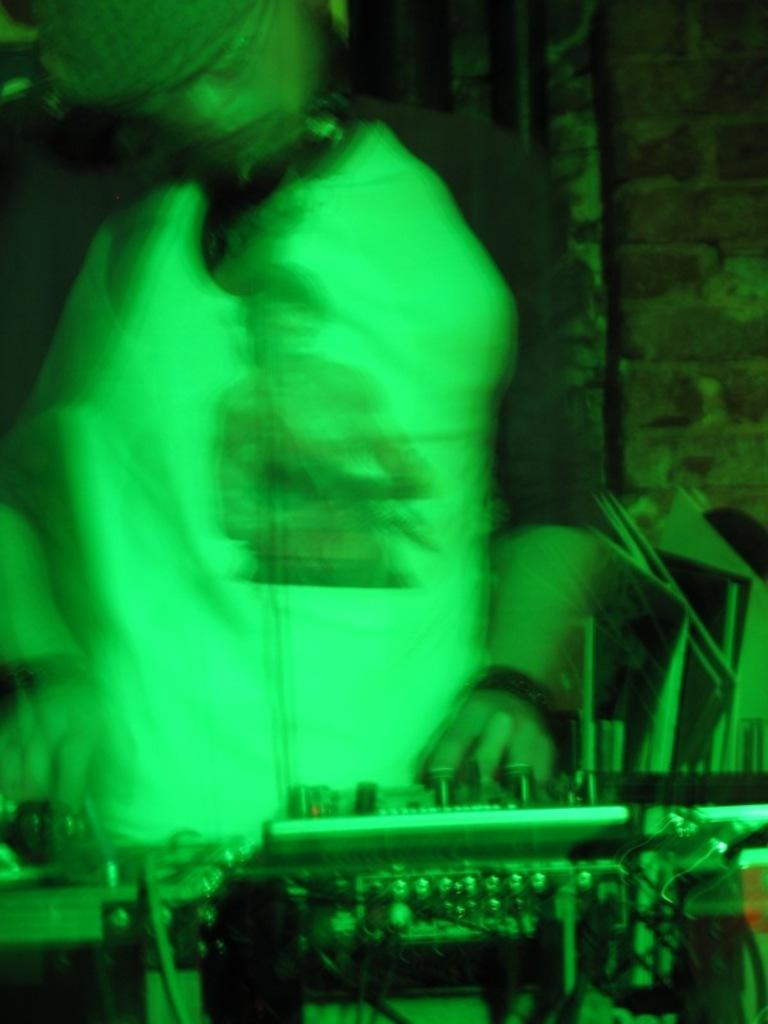What is the main subject of the image? There is a person in the image. What is the person doing or standing near in the image? The person is in front of a musical instrument. Can you describe the quality of the image? The image is blurred. What time is displayed on the hour hand of the clock in the image? There is no clock or hour hand present in the image. What type of vest is the person wearing in the image? There is no vest visible in the image. 